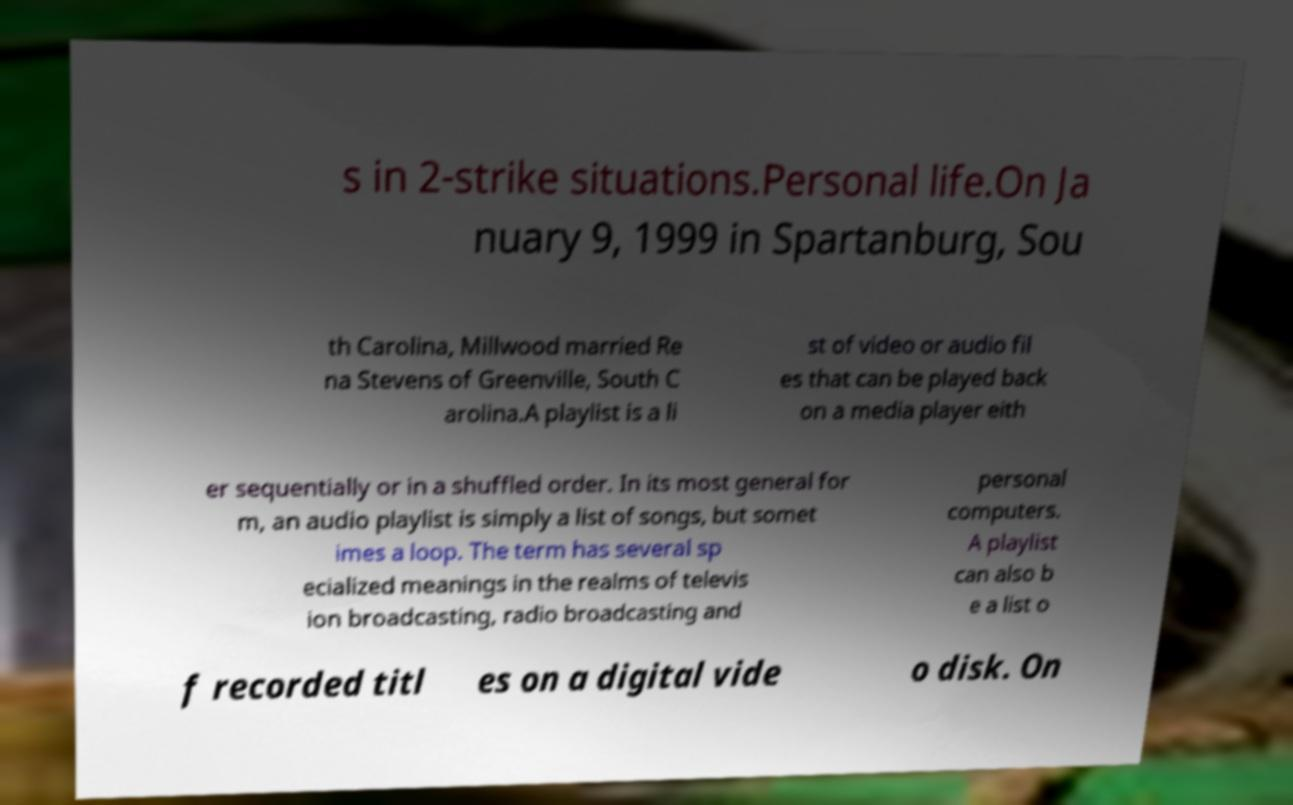What messages or text are displayed in this image? I need them in a readable, typed format. s in 2-strike situations.Personal life.On Ja nuary 9, 1999 in Spartanburg, Sou th Carolina, Millwood married Re na Stevens of Greenville, South C arolina.A playlist is a li st of video or audio fil es that can be played back on a media player eith er sequentially or in a shuffled order. In its most general for m, an audio playlist is simply a list of songs, but somet imes a loop. The term has several sp ecialized meanings in the realms of televis ion broadcasting, radio broadcasting and personal computers. A playlist can also b e a list o f recorded titl es on a digital vide o disk. On 